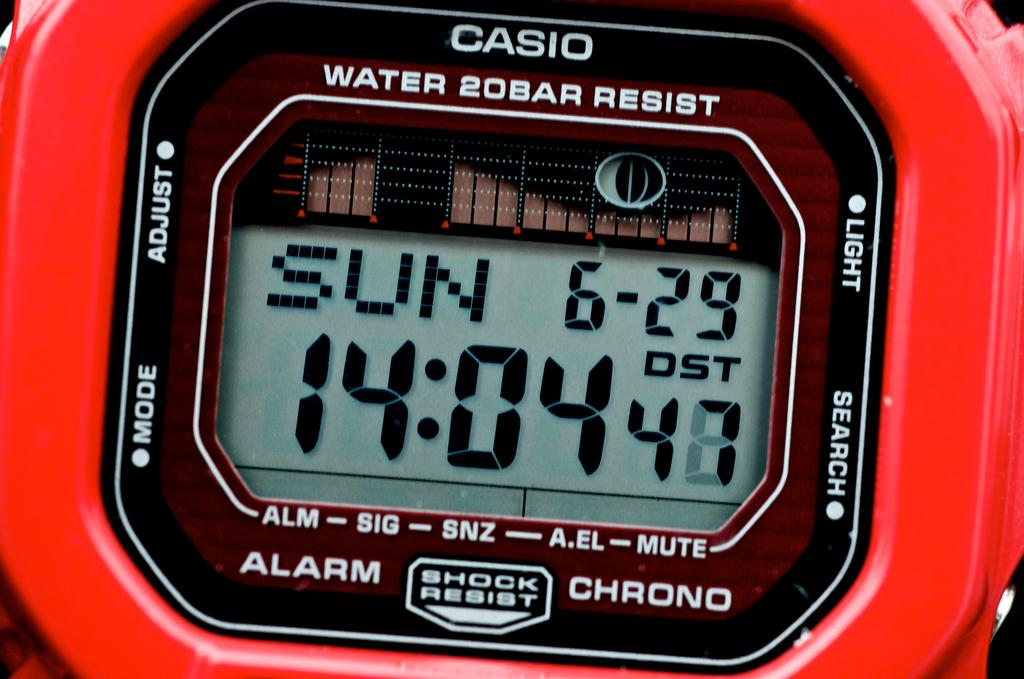<image>
Share a concise interpretation of the image provided. A Casio sports watch shows the day is Sunday. 